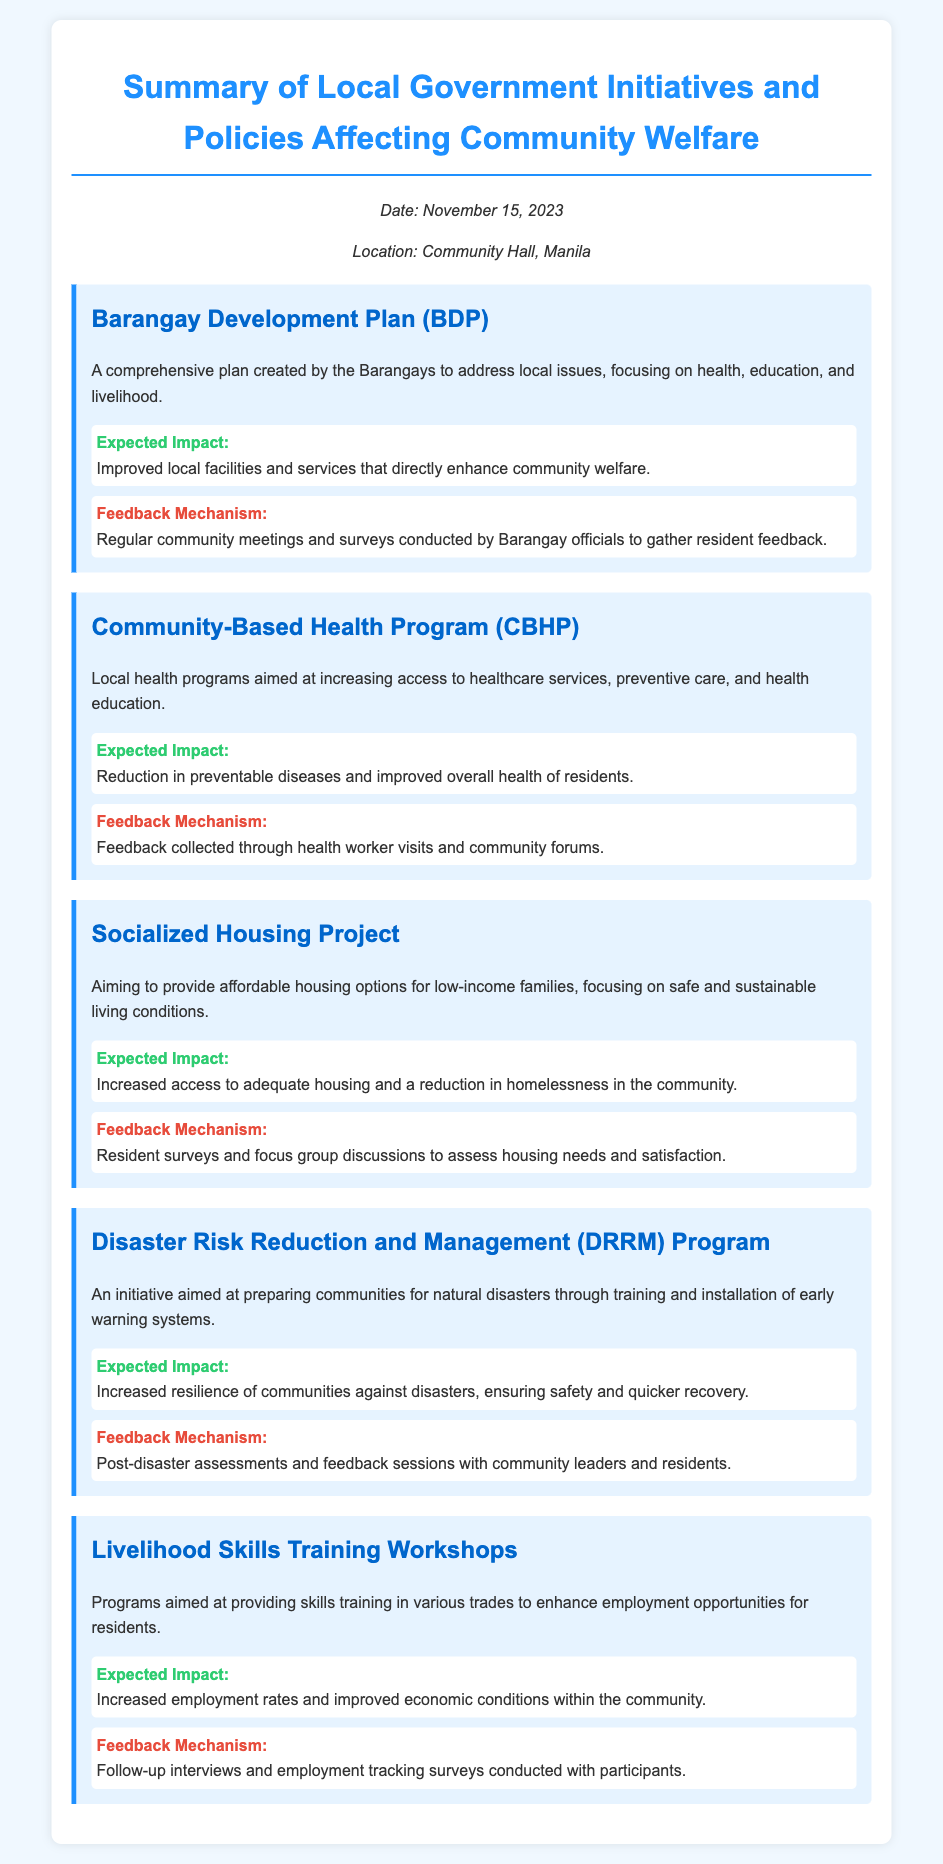What is the date of the document? The date of the document is mentioned in the header information section.
Answer: November 15, 2023 Where was the meeting held? The location of the meeting is specified in the header information section.
Answer: Community Hall, Manila What is the main focus of the Barangay Development Plan? The focus of the Barangay Development Plan is stated clearly in the description provided.
Answer: health, education, and livelihood What is the expected impact of the Community-Based Health Program? This impact is shared in the impact section of the initiative description.
Answer: Reduction in preventable diseases How will feedback be collected for the Socialized Housing Project? The feedback mechanism is outlined in the feedback section of the initiative description.
Answer: Resident surveys and focus group discussions What type of training does the Livelihood Skills Training Workshops provide? The type of training is mentioned in the description of the initiative.
Answer: skills training in various trades What is the objective of the Disaster Risk Reduction and Management Program? The objective is detailed in the description of the initiative.
Answer: Preparing communities for natural disasters Which initiative aims to increase access to adequate housing? The initiative with this aim is specified by its title and description.
Answer: Socialized Housing Project What is the impact of the Livelihood Skills Training Workshops on the community? The impact is stated in the impact section for this initiative.
Answer: Increased employment rates 